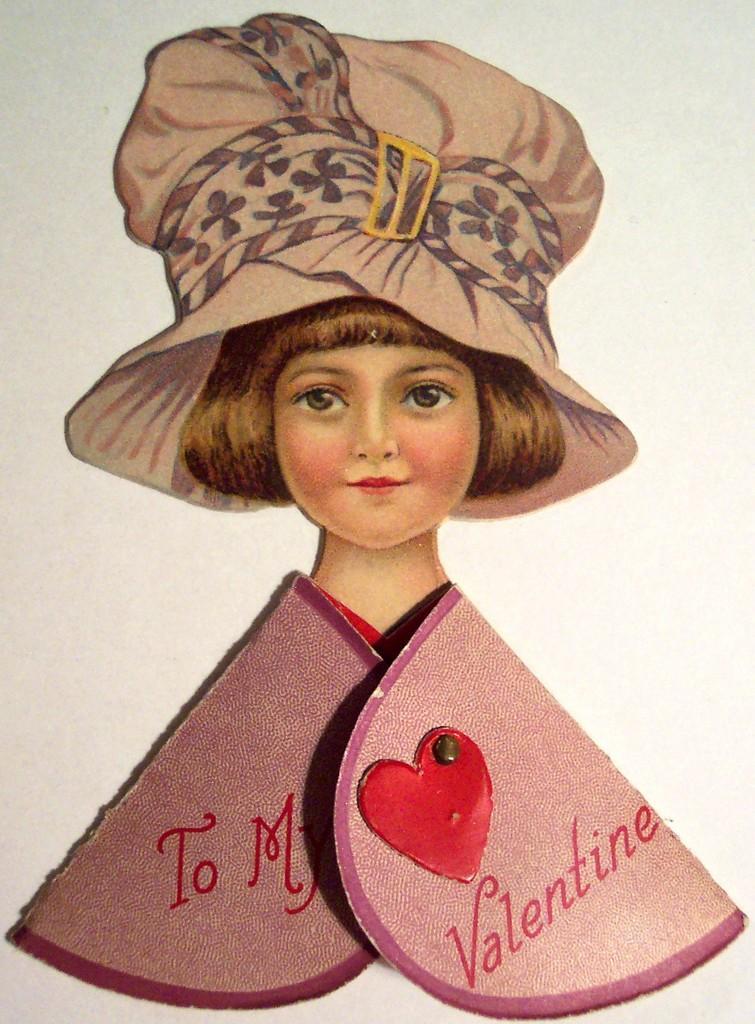In one or two sentences, can you explain what this image depicts? In this image we can see the depiction of a person wearing the cap. We can also see the cardboard pieces with text and also the heart symbol. 